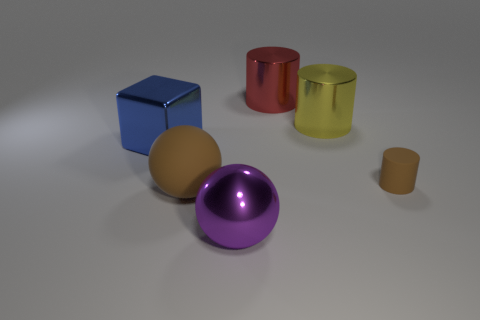Is the number of brown matte objects that are in front of the brown ball the same as the number of metal balls that are in front of the tiny brown matte cylinder? Upon examining the image, we notice that in front of the brown ball, there is indeed one brown matte cube. Comparing this to the number of metal balls in front of the tiny brown matte cylinder, we observe no metal balls fitting that description. Therefore, the correct answer to the question is that no, the number of brown matte objects in front of the brown ball is not the same as the number of metal balls in front of the tiny brown matte cylinder, because there are no metal balls in front of the tiny brown matte cylinder at all. 